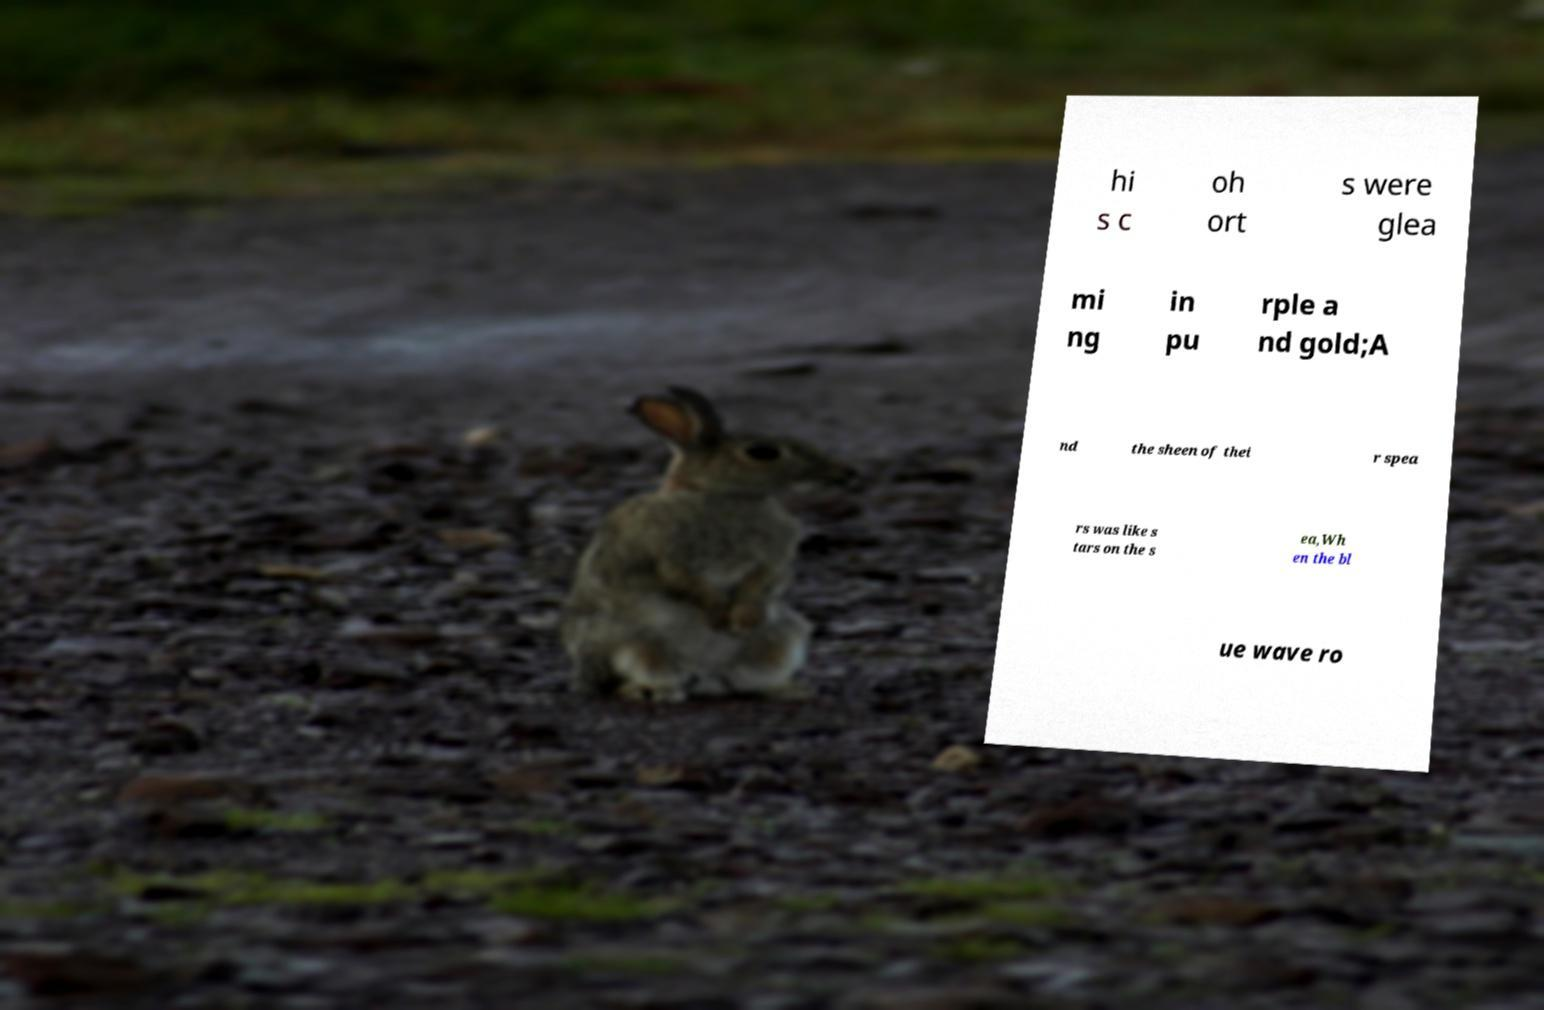For documentation purposes, I need the text within this image transcribed. Could you provide that? hi s c oh ort s were glea mi ng in pu rple a nd gold;A nd the sheen of thei r spea rs was like s tars on the s ea,Wh en the bl ue wave ro 